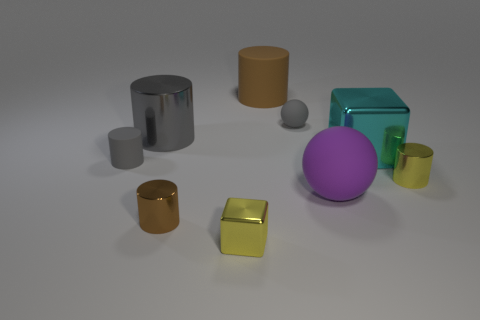Can you describe the lighting source in the scene based on the shadows? The shadows on the ground suggest that there is a single light source located above and to the right of the scene, casting soft-edged shadows to the left of the objects. How does the lighting affect the appearance of the materials? The lighting highlights the differences in material properties; the metallic objects reflect light and show highlights while the matte surfaces diffuse light more evenly. 